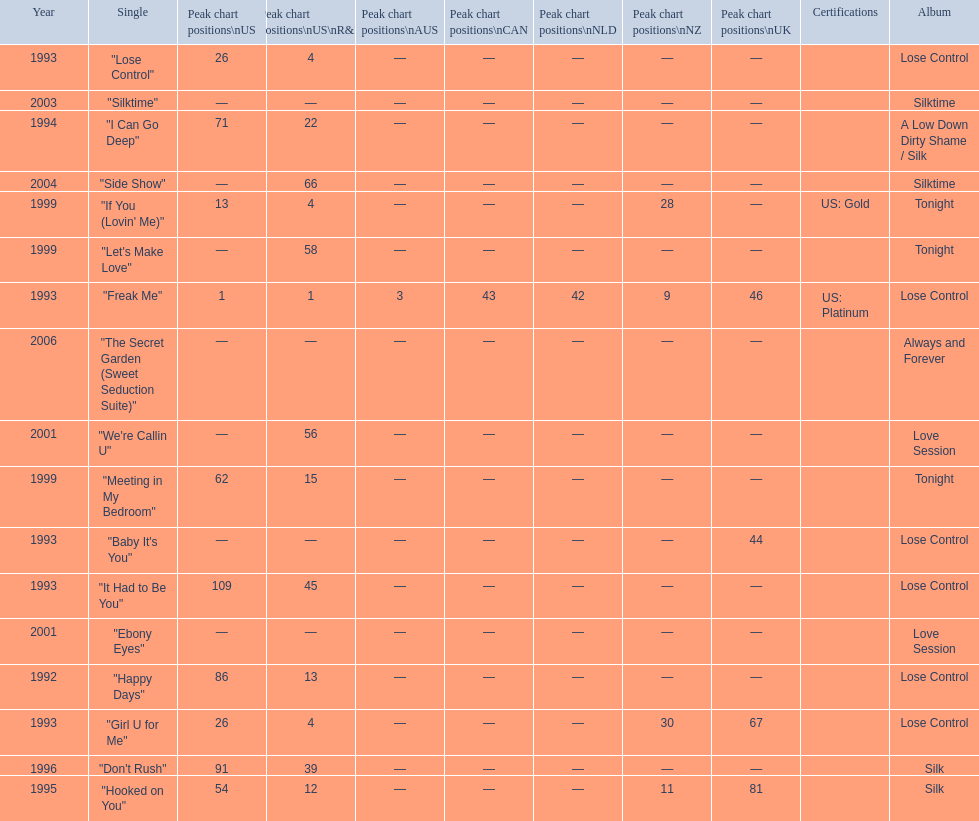Compare "i can go deep" with "don't rush". which was higher on the us and us r&b charts? "I Can Go Deep". 